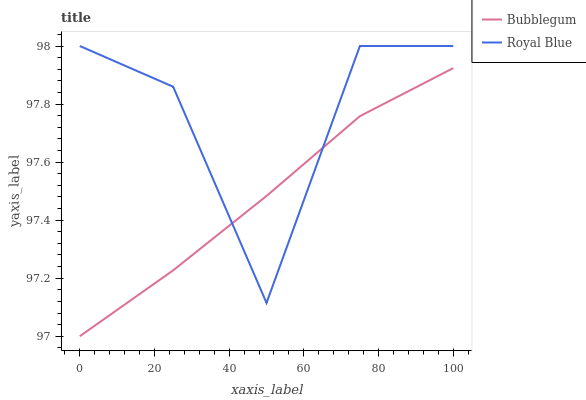Does Bubblegum have the minimum area under the curve?
Answer yes or no. Yes. Does Royal Blue have the maximum area under the curve?
Answer yes or no. Yes. Does Bubblegum have the maximum area under the curve?
Answer yes or no. No. Is Bubblegum the smoothest?
Answer yes or no. Yes. Is Royal Blue the roughest?
Answer yes or no. Yes. Is Bubblegum the roughest?
Answer yes or no. No. Does Bubblegum have the lowest value?
Answer yes or no. Yes. Does Royal Blue have the highest value?
Answer yes or no. Yes. Does Bubblegum have the highest value?
Answer yes or no. No. Does Royal Blue intersect Bubblegum?
Answer yes or no. Yes. Is Royal Blue less than Bubblegum?
Answer yes or no. No. Is Royal Blue greater than Bubblegum?
Answer yes or no. No. 